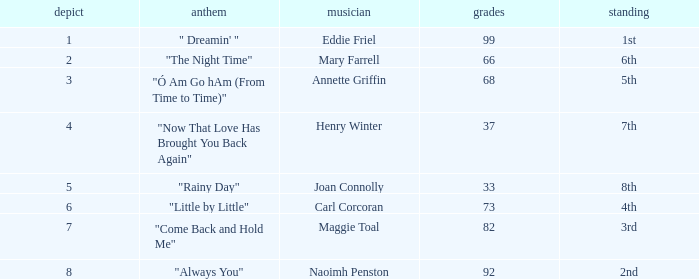What is the typical amount of points when the rank is 7th and the draw is under 4? None. 